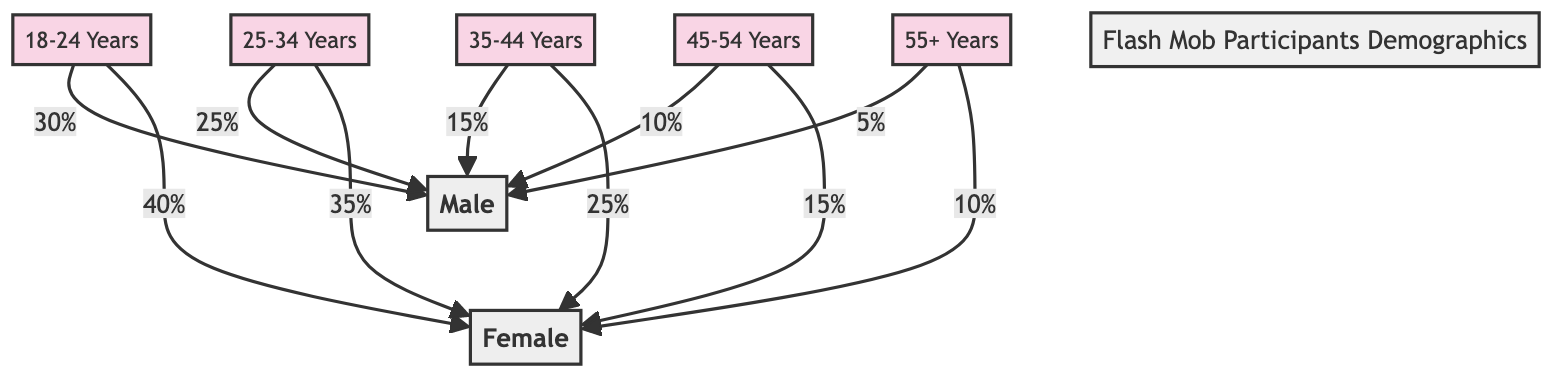What's the percentage of male participants in the age group 18-24? The diagram shows that for the age group 18-24 years, the male participants account for 30%.
Answer: 30% What is the total percentage of female participants in the age group 25-34? In the age group 25-34, female participants make up 35%.
Answer: 35% How many age groups are represented in the diagram? The diagram presents five distinct age groups: 18-24, 25-34, 35-44, 45-54, and 55+.
Answer: 5 What is the total percentage of male participants across all age groups? By summing the percentages of males in each age group: 30% + 25% + 15% + 10% + 5%, the total is 85%.
Answer: 85% Which age group has the highest percentage of female participants? The highest percentage of female participants is found in the age group 18-24 years with 40%.
Answer: 18-24 Years What is the combined percentage of participants aged 35 and older for males? Combining the male percentages from age groups 35-44 (15%), 45-54 (10%), and 55+ (5%), the total is 30%.
Answer: 30% What is the difference in percentage of male and female participants in the age group 45-54? In this age group, male participants are 10% and female participants are 15%. The difference is 15% - 10% = 5%.
Answer: 5% How many total percentages of female participants are listed in the diagram? The diagram indicates: 40%, 35%, 25%, 15%, and 10%, so there are five percentages for female participants.
Answer: 5 Which gender has a larger representation in the age group 35-44? In the 35-44 age group, female participants at 25% surpass male participants at 15%.
Answer: Female 